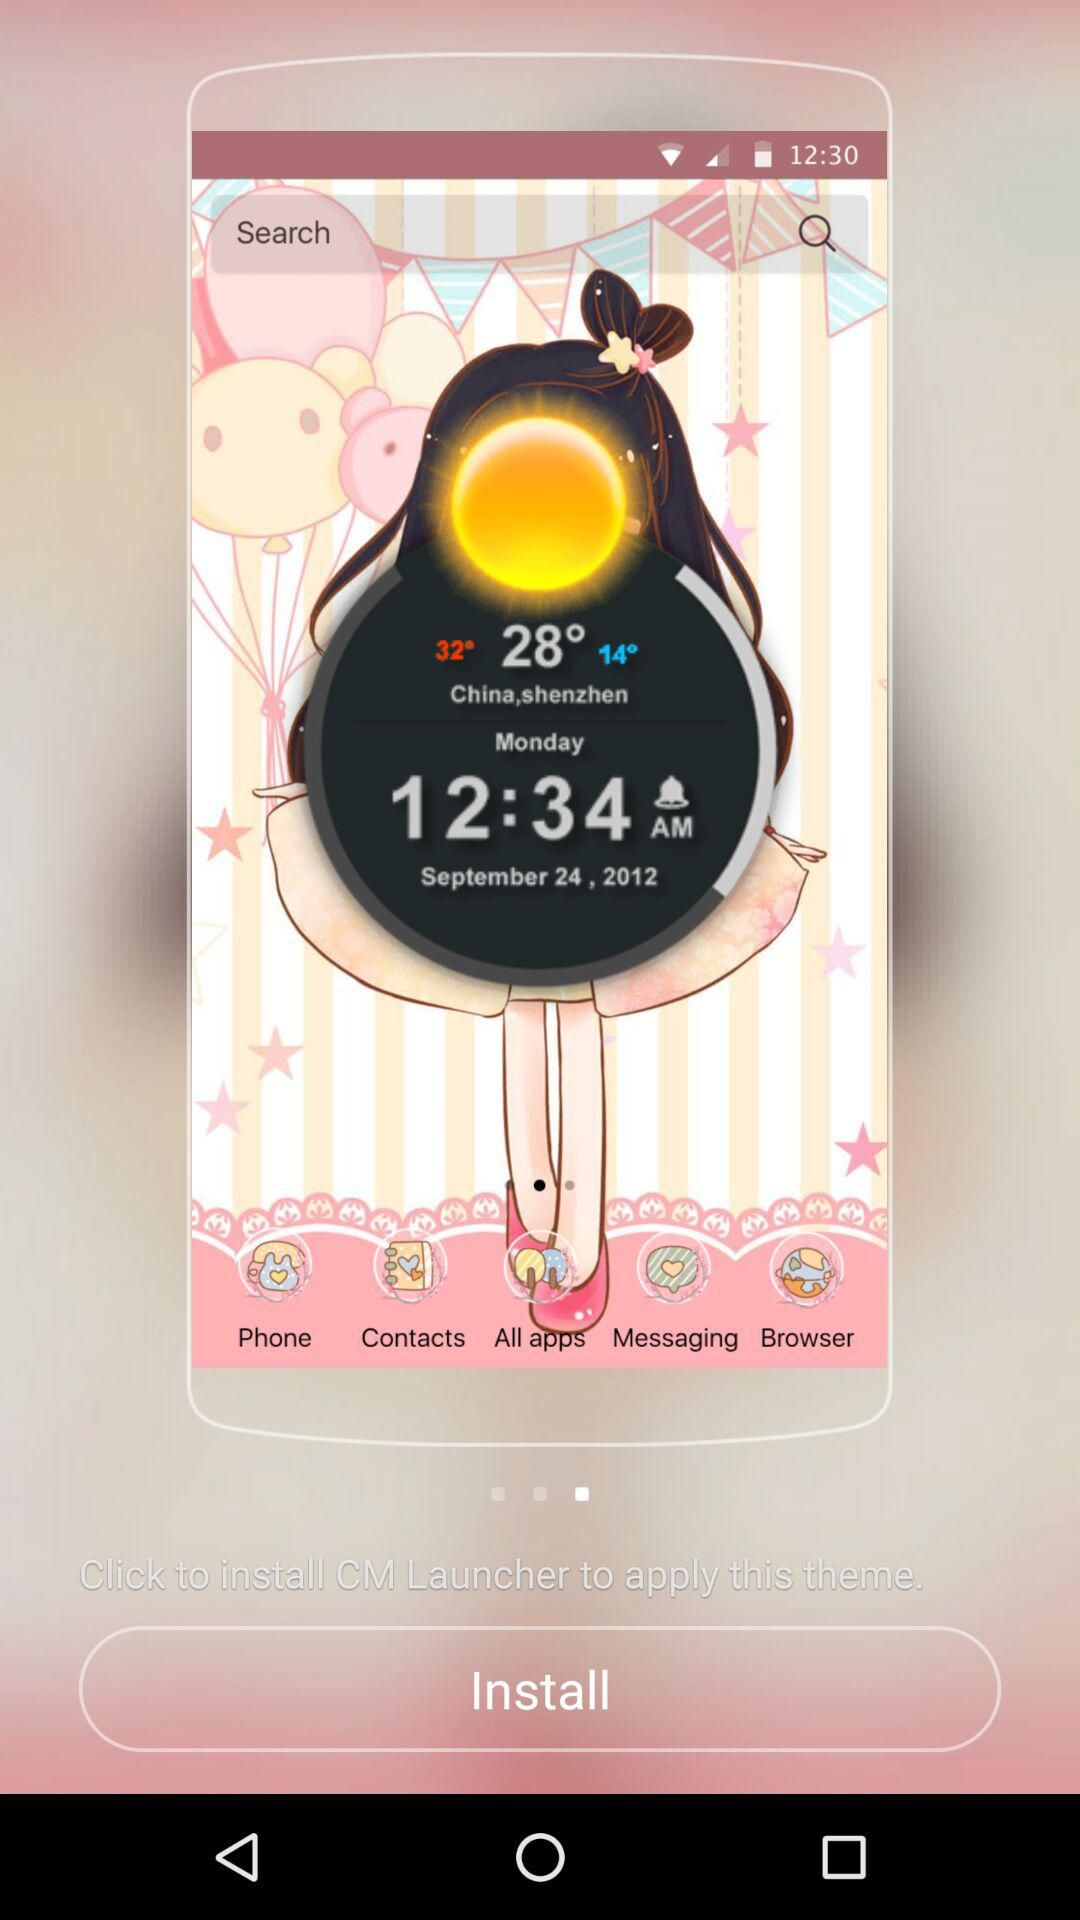What is the minimum temperature?
When the provided information is insufficient, respond with <no answer>. <no answer> 